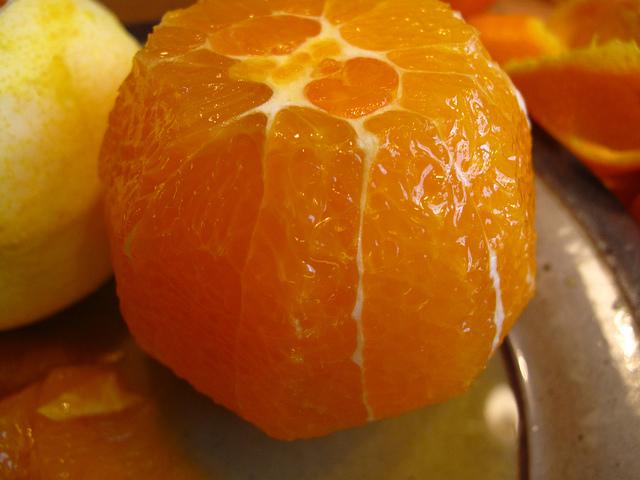Is this a mango?
Keep it brief. No. Is this a fruit or a vegetable?
Give a very brief answer. Fruit. Is this orange peeled too close to the skin?
Concise answer only. No. 